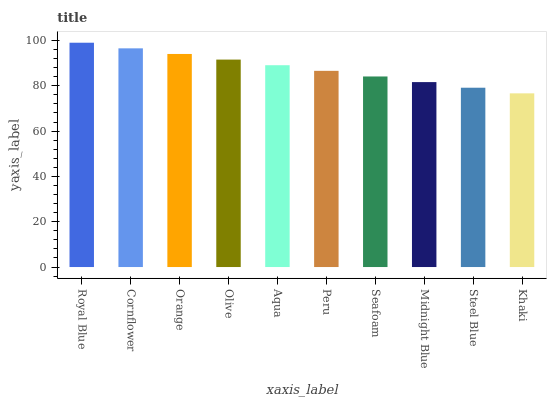Is Khaki the minimum?
Answer yes or no. Yes. Is Royal Blue the maximum?
Answer yes or no. Yes. Is Cornflower the minimum?
Answer yes or no. No. Is Cornflower the maximum?
Answer yes or no. No. Is Royal Blue greater than Cornflower?
Answer yes or no. Yes. Is Cornflower less than Royal Blue?
Answer yes or no. Yes. Is Cornflower greater than Royal Blue?
Answer yes or no. No. Is Royal Blue less than Cornflower?
Answer yes or no. No. Is Aqua the high median?
Answer yes or no. Yes. Is Peru the low median?
Answer yes or no. Yes. Is Olive the high median?
Answer yes or no. No. Is Cornflower the low median?
Answer yes or no. No. 